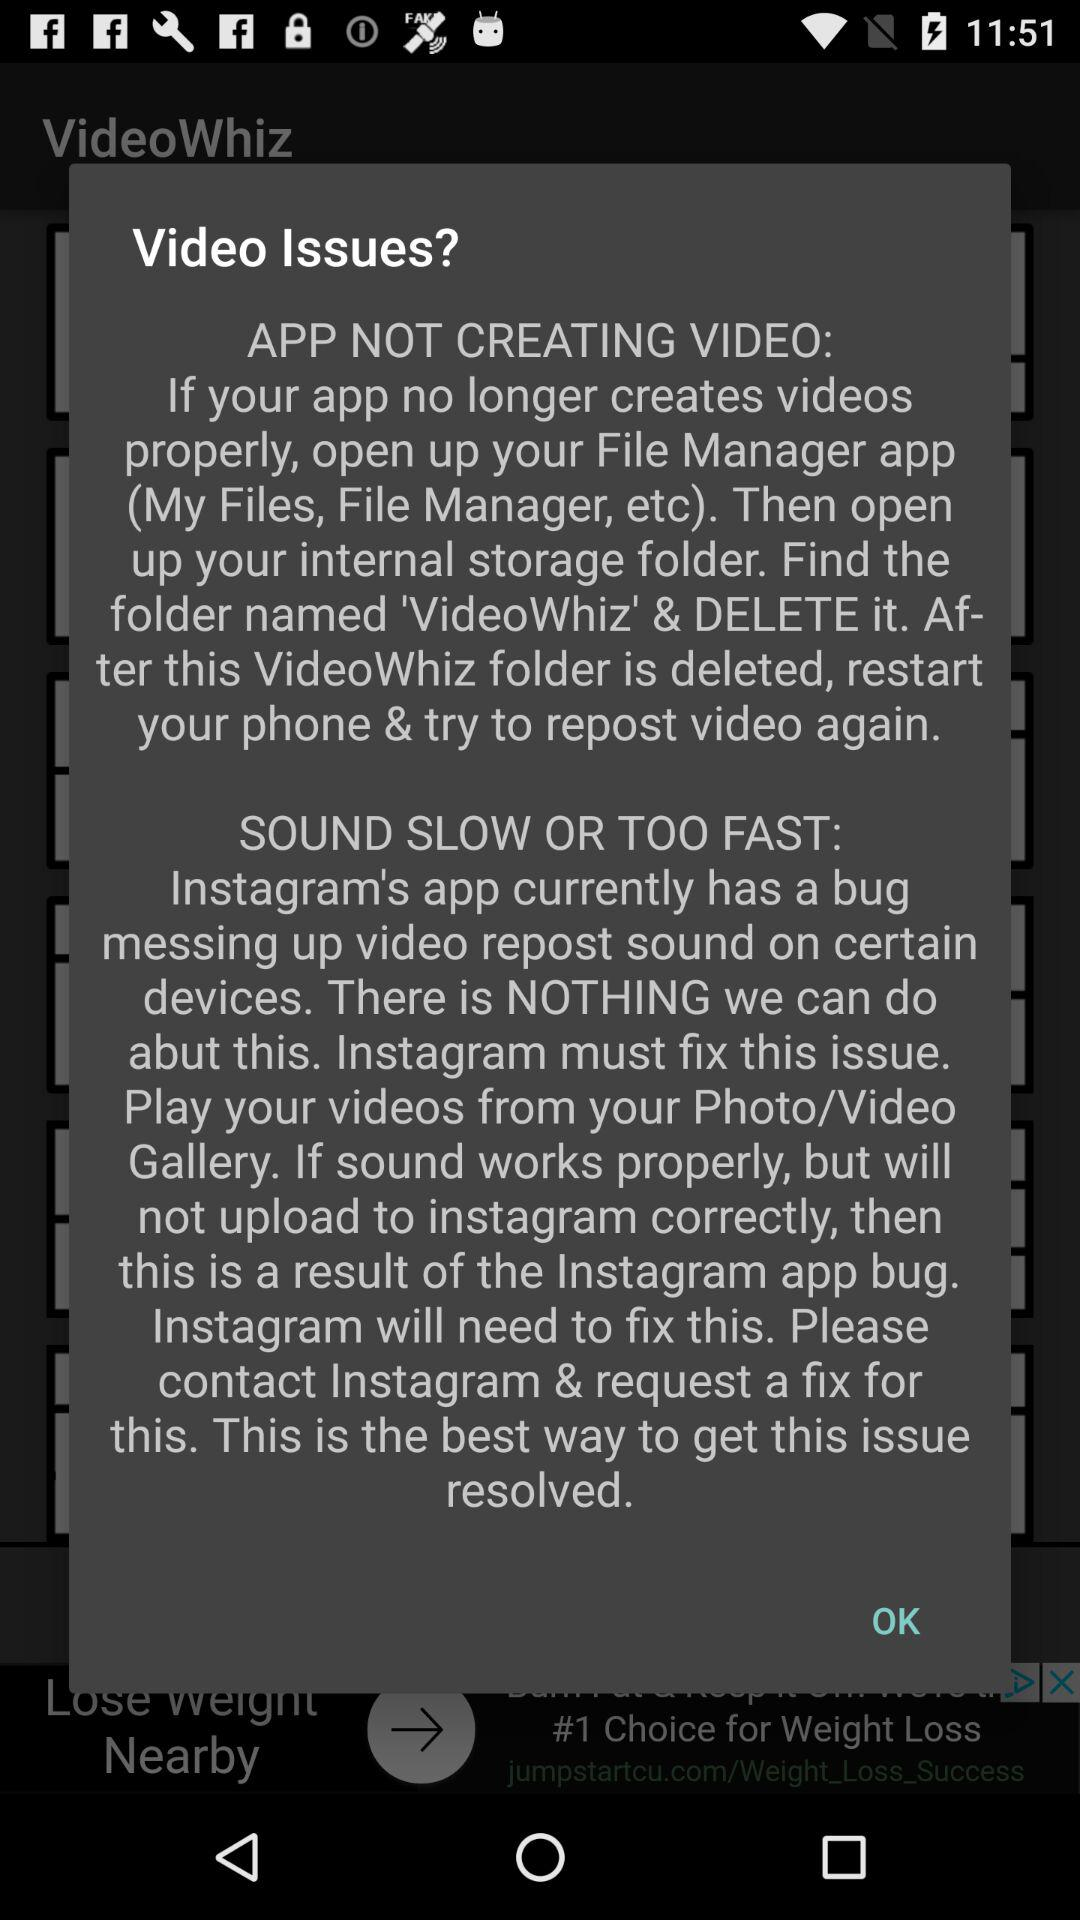How many more sentences are in the text about sound issues than the text about app issues?
Answer the question using a single word or phrase. 2 